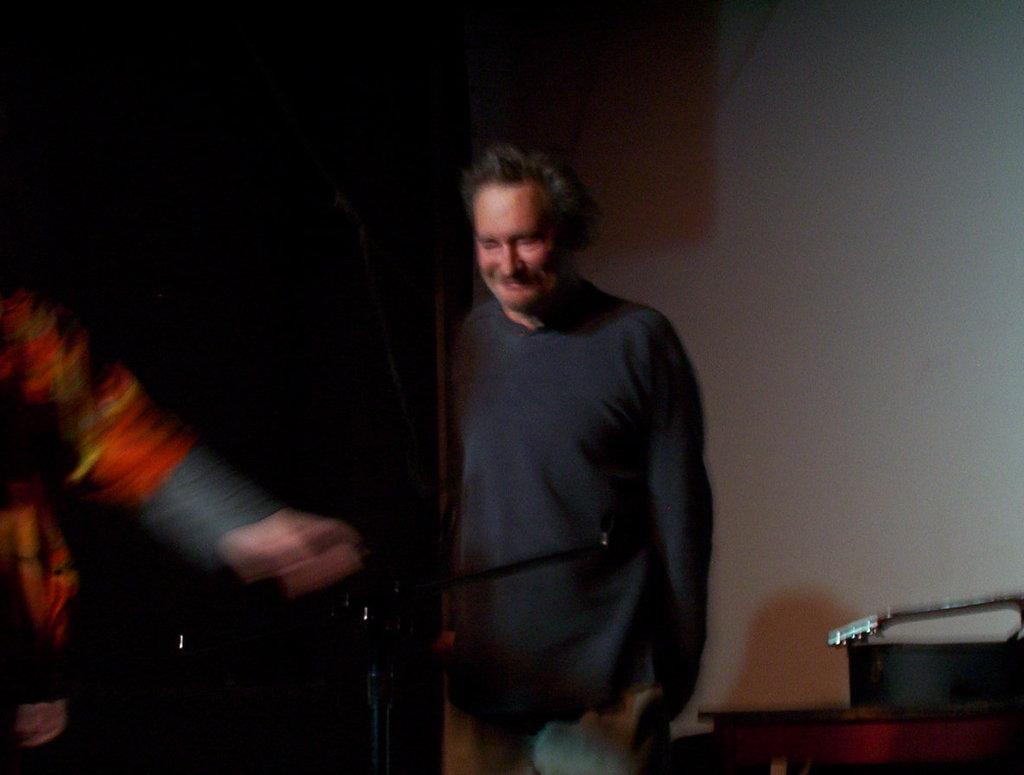What is the main object in the image? There is a stand in the image. How many people are in the image? There are two people in the image. Can you describe the man in the image? A man is standing and smiling in the image. What can be seen behind the man? There are objects behind the man. What is the color of the background in the image? The background of the image is dark. What type of note is the man holding in the image? There is no note present in the image; the man is not holding anything. Can you tell me where the park is located in the image? There is no park present in the image. 